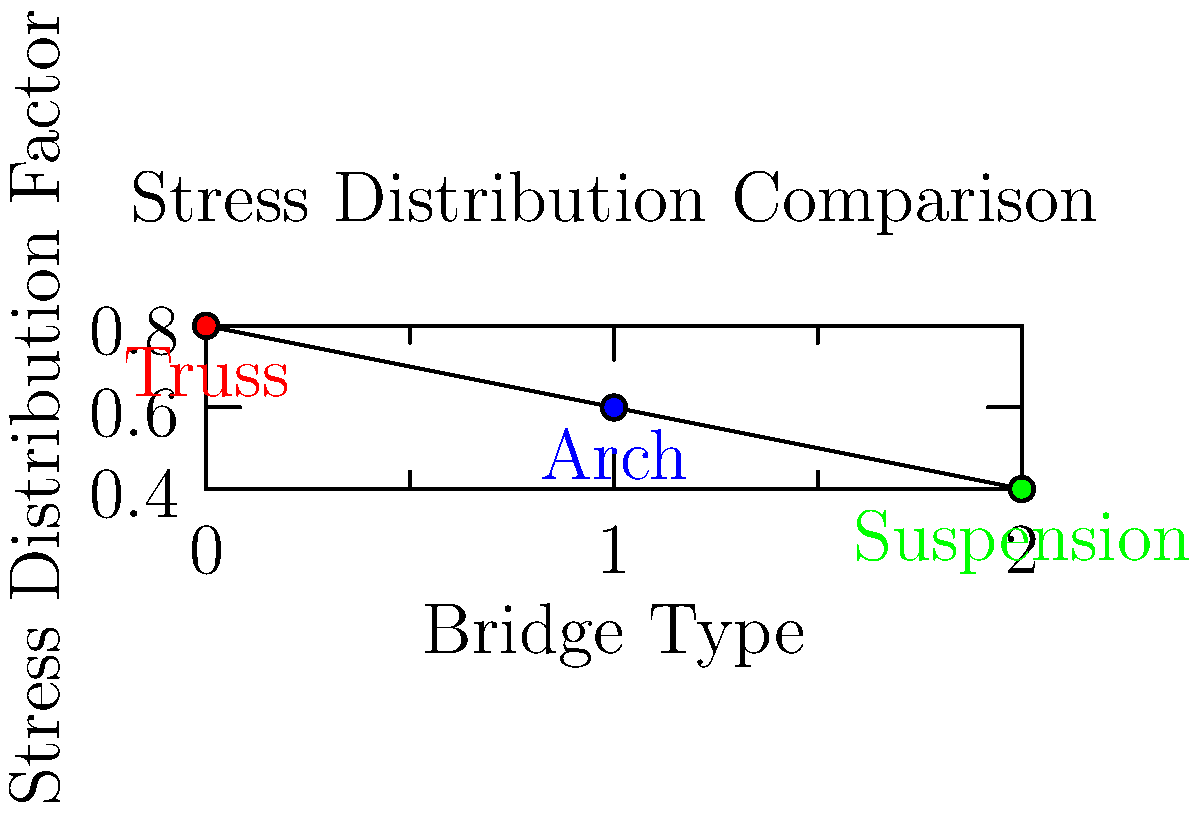As a supporter of community development projects, you're reviewing a proposal for a new bridge. The graph shows the stress distribution factors for different bridge support structures. Which structure type would you recommend to the developers for minimizing stress concentration and potentially reducing maintenance costs, thereby supporting long-term economic growth? To answer this question, we need to analyze the stress distribution factors shown in the graph for each bridge type:

1. Truss bridge: Stress distribution factor ≈ 0.8
2. Arch bridge: Stress distribution factor ≈ 0.6
3. Suspension bridge: Stress distribution factor ≈ 0.4

The stress distribution factor indicates how evenly the stress is distributed throughout the structure. A lower factor means better stress distribution, which typically results in:

1. Reduced likelihood of structural failure
2. Lower maintenance requirements
3. Longer lifespan of the structure

Step-by-step analysis:
1. The suspension bridge has the lowest stress distribution factor (0.4).
2. Lower stress concentration means less wear and tear on specific points of the structure.
3. This leads to potentially lower maintenance costs over time.
4. Reduced maintenance costs contribute to long-term economic benefits for the community.
5. A longer-lasting bridge with lower maintenance needs aligns with the goal of supporting economic growth.

Therefore, based on the stress distribution data and considering the long-term economic impact, the suspension bridge would be the recommended choice for the developers.
Answer: Suspension bridge 